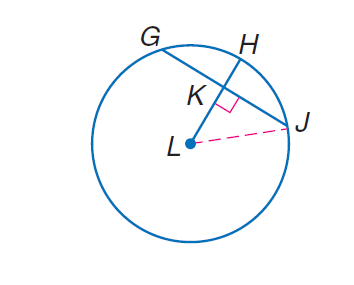Answer the mathemtical geometry problem and directly provide the correct option letter.
Question: Circle L has a radius of 32 centimeters. L H \perp G J, and G J = 40 centimeters. Find L K.
Choices: A: 20 B: \sqrt { 624 } C: 40 D: 624 B 